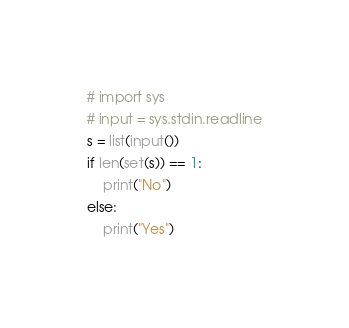<code> <loc_0><loc_0><loc_500><loc_500><_Python_># import sys
# input = sys.stdin.readline
s = list(input())
if len(set(s)) == 1:
    print("No")
else:
    print("Yes")</code> 